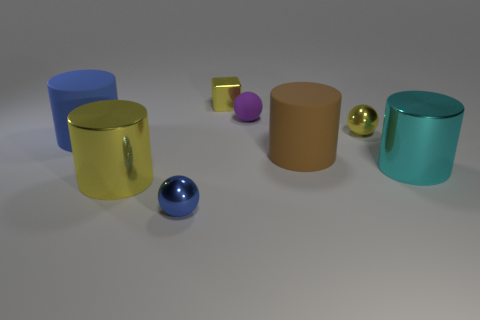How many other objects are the same shape as the blue matte object?
Your response must be concise. 3. There is a sphere that is in front of the yellow ball; what is its size?
Your answer should be very brief. Small. What number of big yellow metal things are to the right of the large metal cylinder left of the cyan metal cylinder?
Your response must be concise. 0. How many other things are there of the same size as the blue metal sphere?
Your answer should be compact. 3. There is a yellow object right of the tiny purple thing; is its shape the same as the blue matte thing?
Your response must be concise. No. What number of shiny objects are both behind the tiny matte object and left of the small blue thing?
Your response must be concise. 0. What material is the large cyan thing?
Ensure brevity in your answer.  Metal. Are there any other things that are the same color as the tiny cube?
Your response must be concise. Yes. Are the small yellow sphere and the large brown thing made of the same material?
Make the answer very short. No. There is a big matte cylinder left of the small sphere that is in front of the large blue thing; what number of large cyan metal cylinders are to the right of it?
Ensure brevity in your answer.  1. 